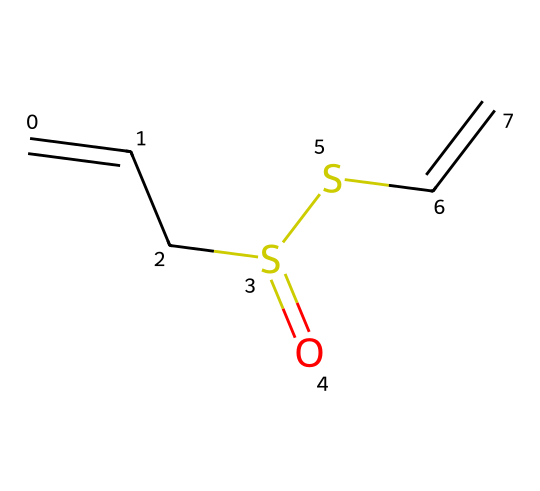What is the main functional group present in allicin? The chemical structure shows the presence of a sulfoxide group (S=O) as indicated by the sulfur atom bonded to an oxygen atom with a double bond, making it the main functional group.
Answer: sulfoxide How many double bonds are present in the allicin molecule? By examining the structure, there are two locations where double bonds are indicated: between the carbon atoms connected to the sulfur atoms, confirming that there are two double bonds.
Answer: 2 What is the total number of sulfur atoms in allicin? The structure contains two sulfur atoms, visually confirmed by identifying the 'S' symbols in the SMILES representation.
Answer: 2 Which part of the structure contributes to the pungent aroma associated with garlic? The sulfur atoms in the structure contribute to the characteristic pungent aroma, as organosulfur compounds are known for this property.
Answer: sulfur atoms What type of chemical bonding is primarily involved in the allicin structure? The presence of multiple single and double bonds in the structure indicates that both covalent and presumably polar covalent bonds are significant, typical for organosulfur compounds.
Answer: covalent What is the overall molecular formula of allicin based on the structure? Analyzing the atoms in the SMILES representation reveals that the molecular formula is C6H10S2O, derived from the counting of carbon, hydrogen, sulfur, and oxygen atoms.
Answer: C6H10S2O 